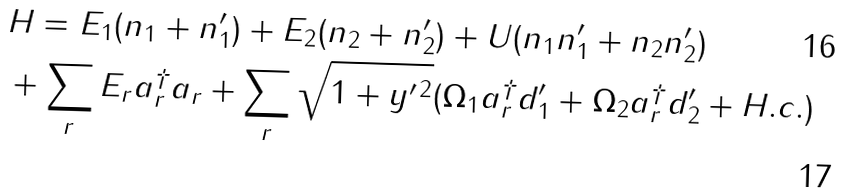Convert formula to latex. <formula><loc_0><loc_0><loc_500><loc_500>& H = E _ { 1 } ( n _ { 1 } + n _ { 1 } ^ { \prime } ) + E _ { 2 } ( n _ { 2 } + n _ { 2 } ^ { \prime } ) + U ( n _ { 1 } n _ { 1 } ^ { \prime } + n _ { 2 } n _ { 2 } ^ { \prime } ) \\ & + \sum _ { r } E _ { r } a _ { r } ^ { \dagger } a _ { r } + \sum _ { r } \sqrt { 1 + y ^ { \prime \, 2 } } ( \Omega _ { 1 } a _ { r } ^ { \dagger } d _ { 1 } ^ { \prime } + \Omega _ { 2 } a _ { r } ^ { \dagger } d _ { 2 } ^ { \prime } + H . c . )</formula> 